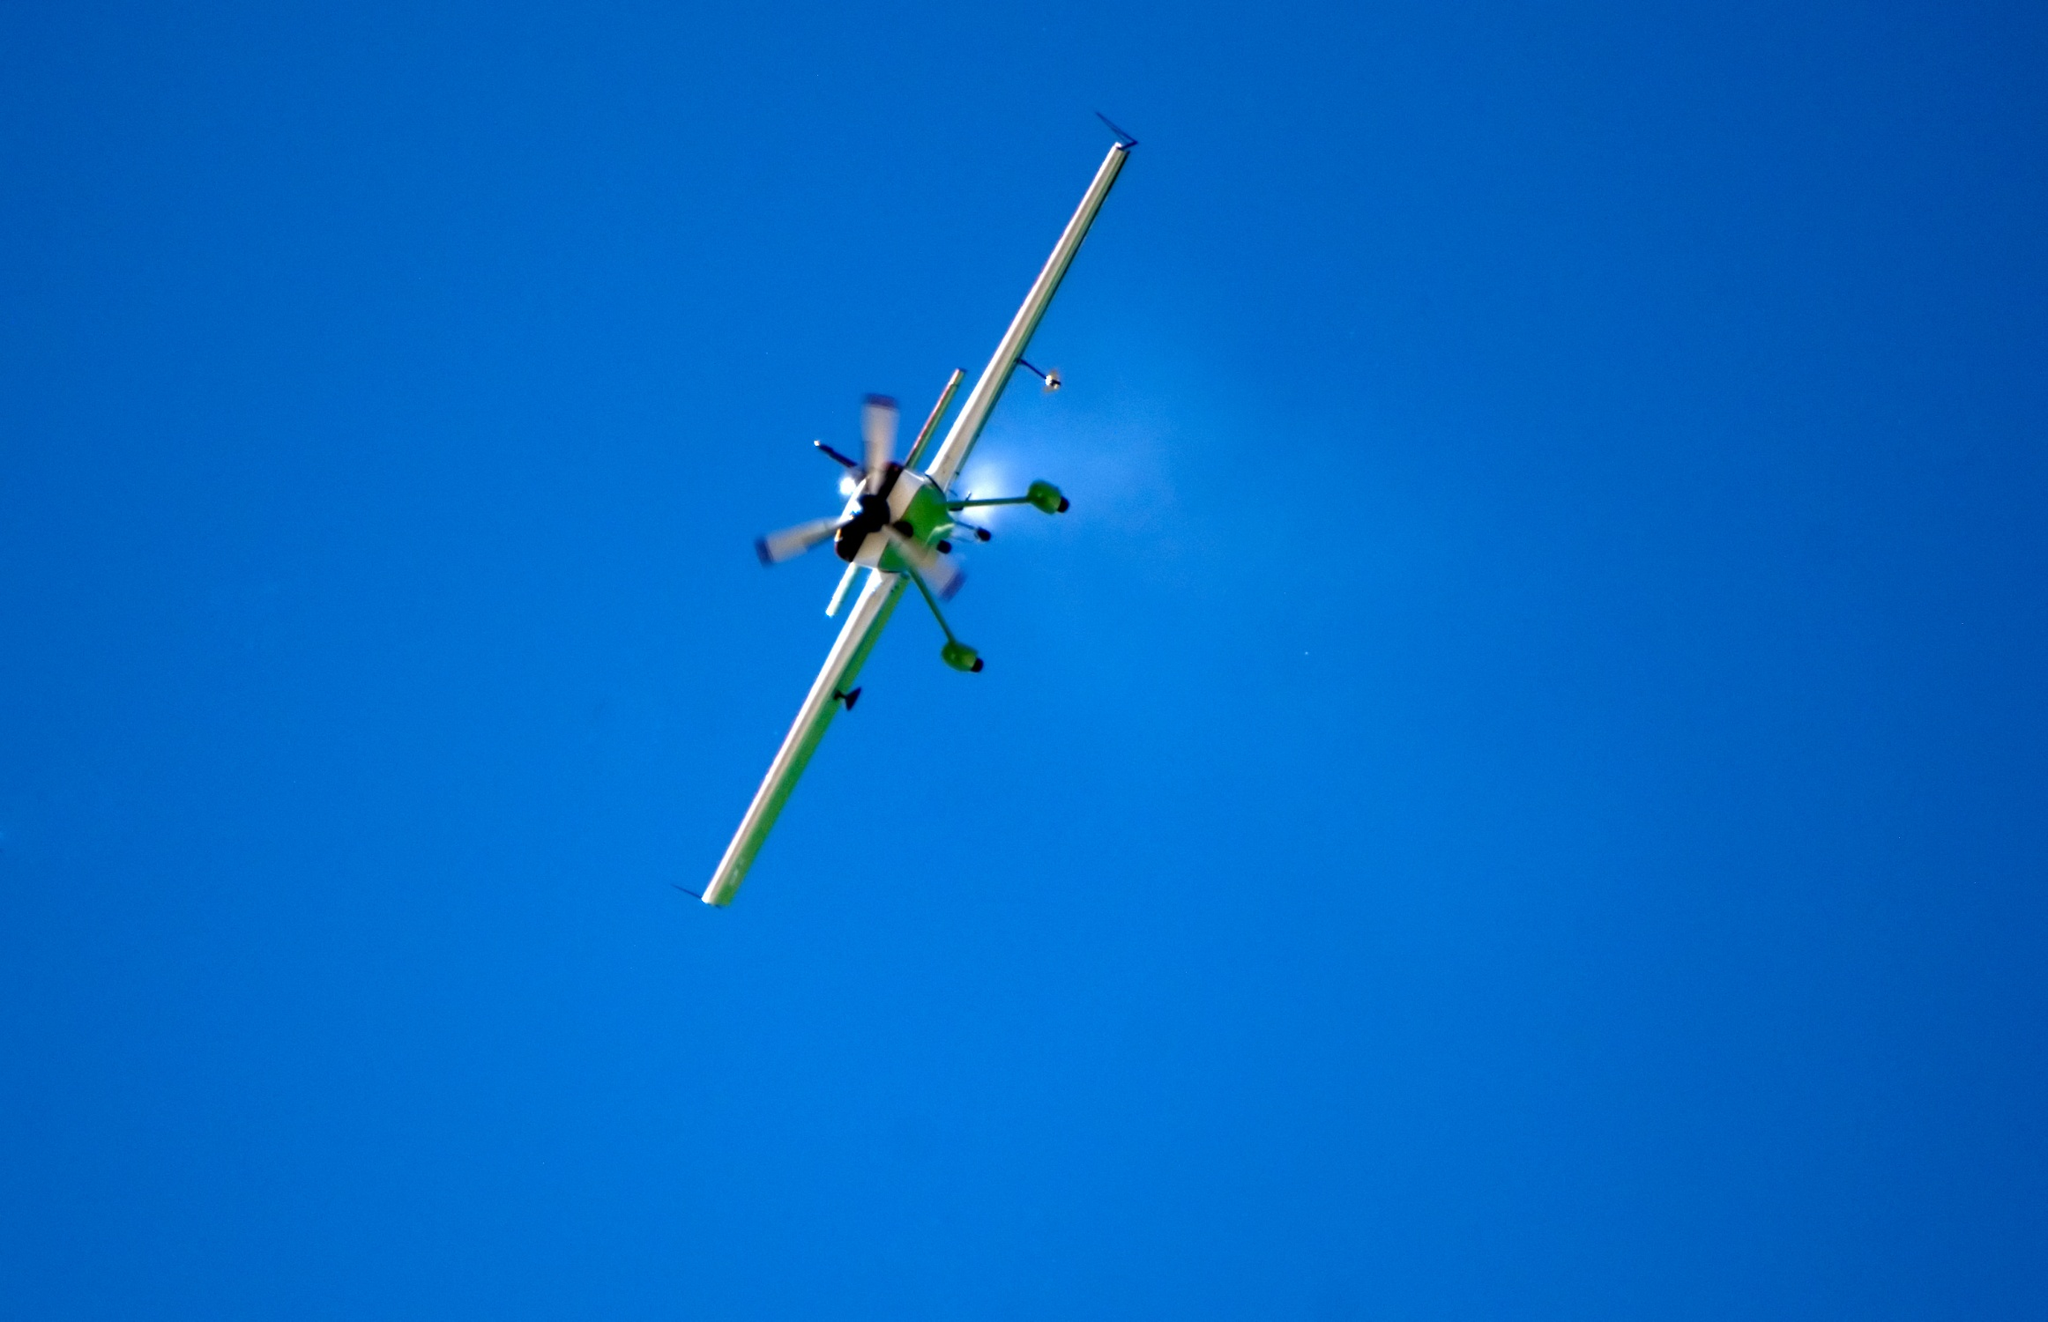How does the background contribute to the overall feel of the image? The stark blue background of the sky provides a stark contrast to the white and green airplane, emphasizing its vibrant colors and the clarity of its form. The uncluttered sky accentuates the feeling of freedom and the thrill of open-air flight, highlighting the airplane's journey and isolated position in the vast expanse. 